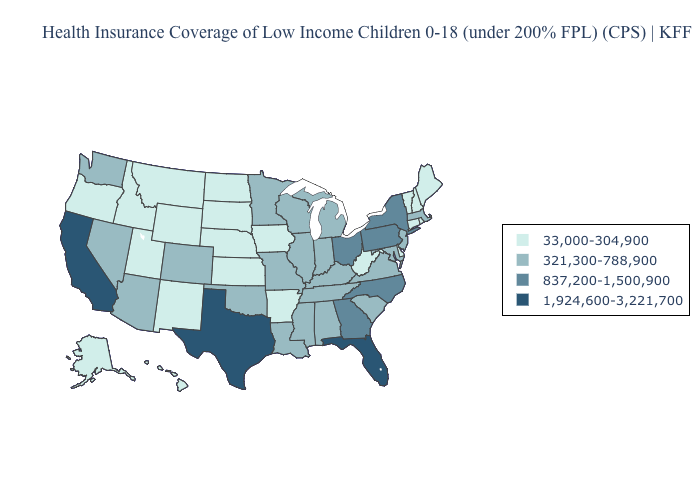Does Texas have the same value as Florida?
Quick response, please. Yes. Does the map have missing data?
Give a very brief answer. No. Name the states that have a value in the range 837,200-1,500,900?
Concise answer only. Georgia, New York, North Carolina, Ohio, Pennsylvania. Does Montana have a higher value than Nebraska?
Be succinct. No. Does Mississippi have the highest value in the USA?
Concise answer only. No. Name the states that have a value in the range 1,924,600-3,221,700?
Give a very brief answer. California, Florida, Texas. What is the value of Montana?
Quick response, please. 33,000-304,900. Name the states that have a value in the range 33,000-304,900?
Answer briefly. Alaska, Arkansas, Connecticut, Delaware, Hawaii, Idaho, Iowa, Kansas, Maine, Montana, Nebraska, New Hampshire, New Mexico, North Dakota, Oregon, Rhode Island, South Dakota, Utah, Vermont, West Virginia, Wyoming. Which states have the highest value in the USA?
Concise answer only. California, Florida, Texas. What is the value of Kansas?
Be succinct. 33,000-304,900. Does Kentucky have the lowest value in the USA?
Write a very short answer. No. Name the states that have a value in the range 33,000-304,900?
Be succinct. Alaska, Arkansas, Connecticut, Delaware, Hawaii, Idaho, Iowa, Kansas, Maine, Montana, Nebraska, New Hampshire, New Mexico, North Dakota, Oregon, Rhode Island, South Dakota, Utah, Vermont, West Virginia, Wyoming. Name the states that have a value in the range 321,300-788,900?
Concise answer only. Alabama, Arizona, Colorado, Illinois, Indiana, Kentucky, Louisiana, Maryland, Massachusetts, Michigan, Minnesota, Mississippi, Missouri, Nevada, New Jersey, Oklahoma, South Carolina, Tennessee, Virginia, Washington, Wisconsin. Does Wyoming have a lower value than Alaska?
Concise answer only. No. 